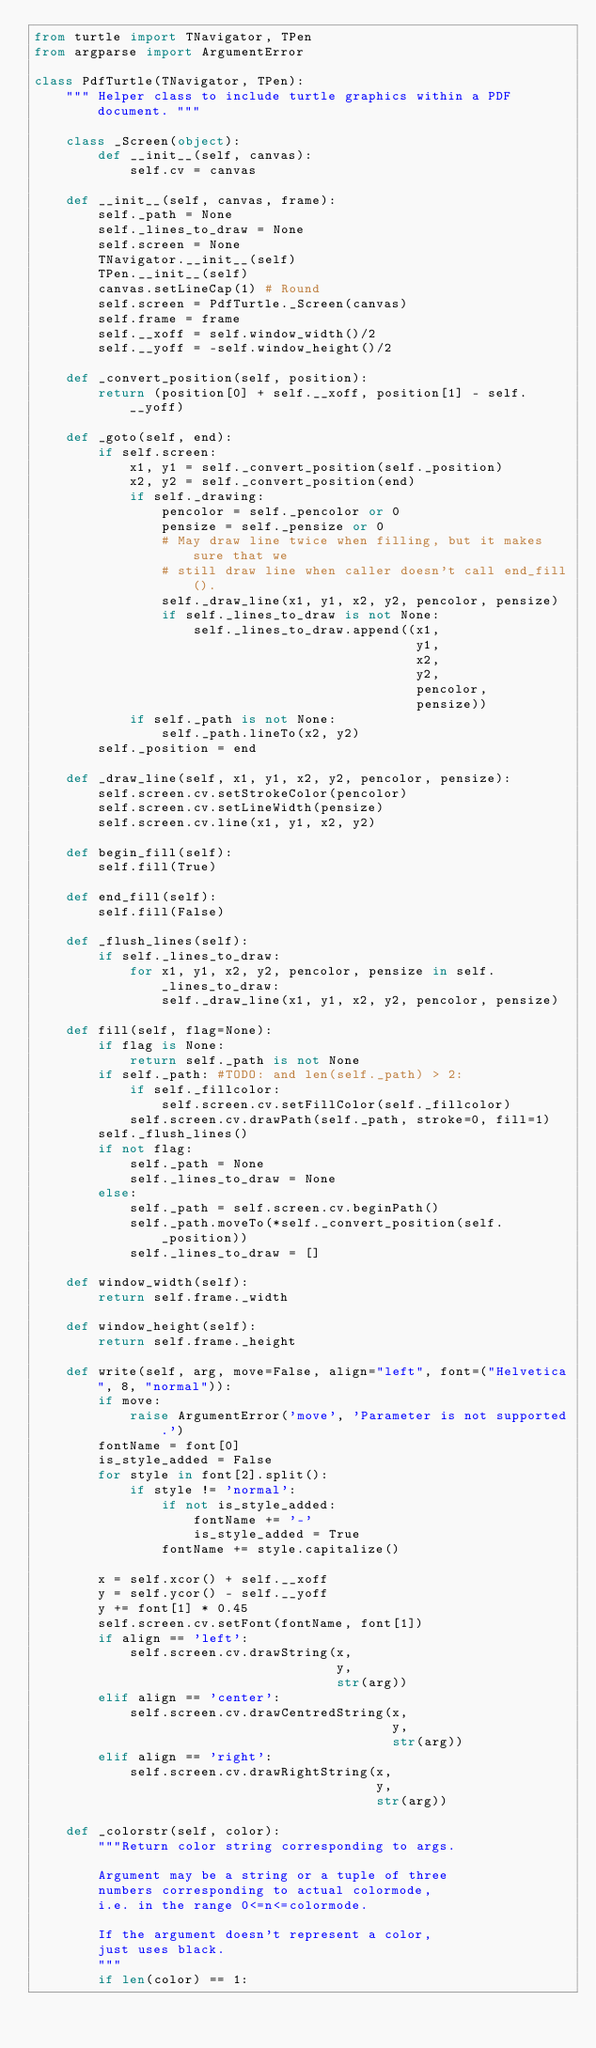Convert code to text. <code><loc_0><loc_0><loc_500><loc_500><_Python_>from turtle import TNavigator, TPen
from argparse import ArgumentError

class PdfTurtle(TNavigator, TPen):
    """ Helper class to include turtle graphics within a PDF document. """
    
    class _Screen(object):
        def __init__(self, canvas):
            self.cv = canvas
            
    def __init__(self, canvas, frame):
        self._path = None
        self._lines_to_draw = None
        self.screen = None
        TNavigator.__init__(self)
        TPen.__init__(self)
        canvas.setLineCap(1) # Round
        self.screen = PdfTurtle._Screen(canvas)
        self.frame = frame
        self.__xoff = self.window_width()/2
        self.__yoff = -self.window_height()/2
        
    def _convert_position(self, position):
        return (position[0] + self.__xoff, position[1] - self.__yoff)
    
    def _goto(self, end):
        if self.screen:
            x1, y1 = self._convert_position(self._position)
            x2, y2 = self._convert_position(end)
            if self._drawing:
                pencolor = self._pencolor or 0
                pensize = self._pensize or 0
                # May draw line twice when filling, but it makes sure that we
                # still draw line when caller doesn't call end_fill().
                self._draw_line(x1, y1, x2, y2, pencolor, pensize)
                if self._lines_to_draw is not None:
                    self._lines_to_draw.append((x1, 
                                                y1, 
                                                x2, 
                                                y2, 
                                                pencolor, 
                                                pensize))
            if self._path is not None:
                self._path.lineTo(x2, y2)
        self._position = end
    
    def _draw_line(self, x1, y1, x2, y2, pencolor, pensize):
        self.screen.cv.setStrokeColor(pencolor)
        self.screen.cv.setLineWidth(pensize)
        self.screen.cv.line(x1, y1, x2, y2)
        
    def begin_fill(self):
        self.fill(True)
        
    def end_fill(self):
        self.fill(False)
        
    def _flush_lines(self):
        if self._lines_to_draw:
            for x1, y1, x2, y2, pencolor, pensize in self._lines_to_draw:
                self._draw_line(x1, y1, x2, y2, pencolor, pensize)

    def fill(self, flag=None):
        if flag is None:
            return self._path is not None
        if self._path: #TODO: and len(self._path) > 2:
            if self._fillcolor:
                self.screen.cv.setFillColor(self._fillcolor)
            self.screen.cv.drawPath(self._path, stroke=0, fill=1)
        self._flush_lines()
        if not flag:
            self._path = None
            self._lines_to_draw = None
        else:
            self._path = self.screen.cv.beginPath()
            self._path.moveTo(*self._convert_position(self._position))
            self._lines_to_draw = []

    def window_width(self):
        return self.frame._width

    def window_height(self):
        return self.frame._height

    def write(self, arg, move=False, align="left", font=("Helvetica", 8, "normal")):
        if move:
            raise ArgumentError('move', 'Parameter is not supported.')
        fontName = font[0]
        is_style_added = False
        for style in font[2].split():
            if style != 'normal':
                if not is_style_added:
                    fontName += '-'
                    is_style_added = True
                fontName += style.capitalize()
        
        x = self.xcor() + self.__xoff
        y = self.ycor() - self.__yoff
        y += font[1] * 0.45
        self.screen.cv.setFont(fontName, font[1])
        if align == 'left':
            self.screen.cv.drawString(x, 
                                      y,
                                      str(arg))
        elif align == 'center':
            self.screen.cv.drawCentredString(x, 
                                             y,
                                             str(arg))
        elif align == 'right':
            self.screen.cv.drawRightString(x, 
                                           y,
                                           str(arg))

    def _colorstr(self, color):
        """Return color string corresponding to args.

        Argument may be a string or a tuple of three
        numbers corresponding to actual colormode,
        i.e. in the range 0<=n<=colormode.

        If the argument doesn't represent a color,
        just uses black.
        """
        if len(color) == 1:</code> 